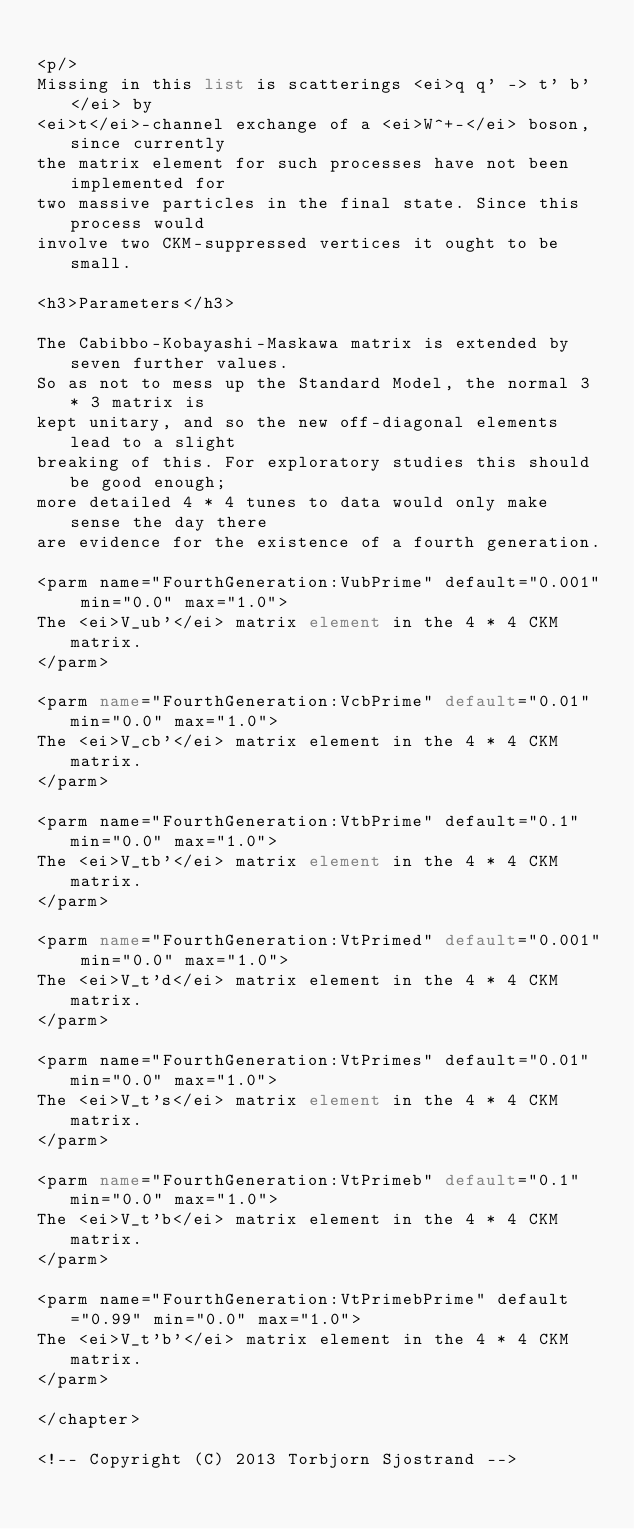<code> <loc_0><loc_0><loc_500><loc_500><_XML_>
<p/>
Missing in this list is scatterings <ei>q q' -> t' b'</ei> by 
<ei>t</ei>-channel exchange of a <ei>W^+-</ei> boson, since currently
the matrix element for such processes have not been implemented for
two massive particles in the final state. Since this process would
involve two CKM-suppressed vertices it ought to be small. 

<h3>Parameters</h3>

The Cabibbo-Kobayashi-Maskawa matrix is extended by seven further values.
So as not to mess up the Standard Model, the normal 3 * 3 matrix is
kept unitary, and so the new off-diagonal elements lead to a slight
breaking of this. For exploratory studies this should be good enough;
more detailed 4 * 4 tunes to data would only make sense the day there
are evidence for the existence of a fourth generation. 

<parm name="FourthGeneration:VubPrime" default="0.001" min="0.0" max="1.0">
The <ei>V_ub'</ei> matrix element in the 4 * 4 CKM matrix.
</parm>

<parm name="FourthGeneration:VcbPrime" default="0.01" min="0.0" max="1.0">
The <ei>V_cb'</ei> matrix element in the 4 * 4 CKM matrix.
</parm>

<parm name="FourthGeneration:VtbPrime" default="0.1" min="0.0" max="1.0">
The <ei>V_tb'</ei> matrix element in the 4 * 4 CKM matrix.
</parm>

<parm name="FourthGeneration:VtPrimed" default="0.001" min="0.0" max="1.0">
The <ei>V_t'd</ei> matrix element in the 4 * 4 CKM matrix.
</parm>

<parm name="FourthGeneration:VtPrimes" default="0.01" min="0.0" max="1.0">
The <ei>V_t's</ei> matrix element in the 4 * 4 CKM matrix.
</parm>

<parm name="FourthGeneration:VtPrimeb" default="0.1" min="0.0" max="1.0">
The <ei>V_t'b</ei> matrix element in the 4 * 4 CKM matrix.
</parm>

<parm name="FourthGeneration:VtPrimebPrime" default="0.99" min="0.0" max="1.0">
The <ei>V_t'b'</ei> matrix element in the 4 * 4 CKM matrix.
</parm> 

</chapter>

<!-- Copyright (C) 2013 Torbjorn Sjostrand -->

</code> 